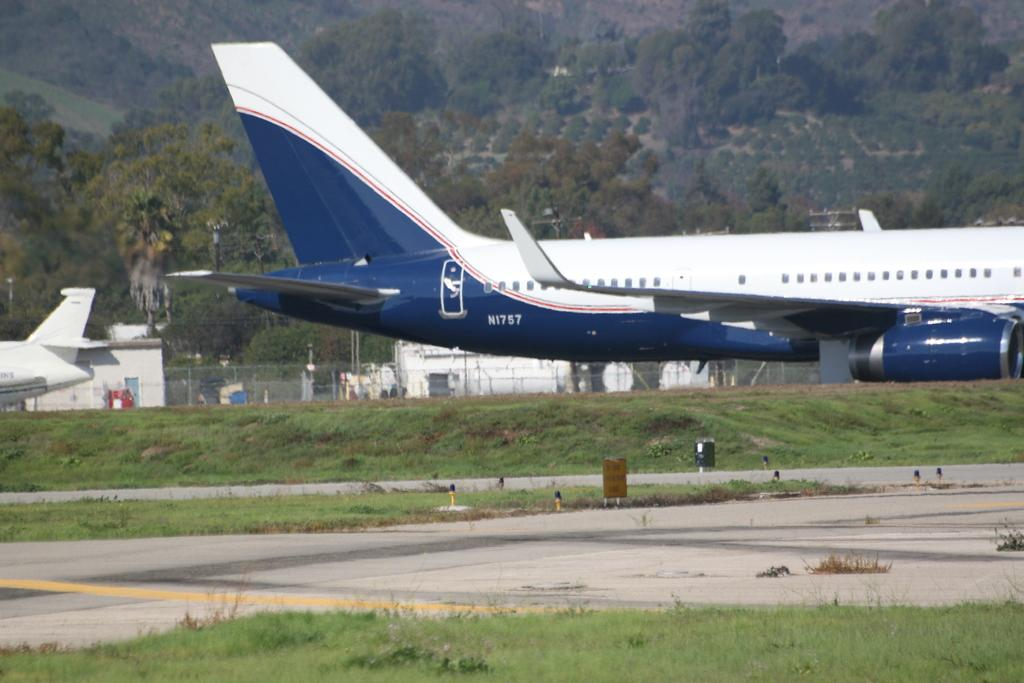Provide a one-sentence caption for the provided image. Airplane with the plate "N1757" is parked on the runway. 